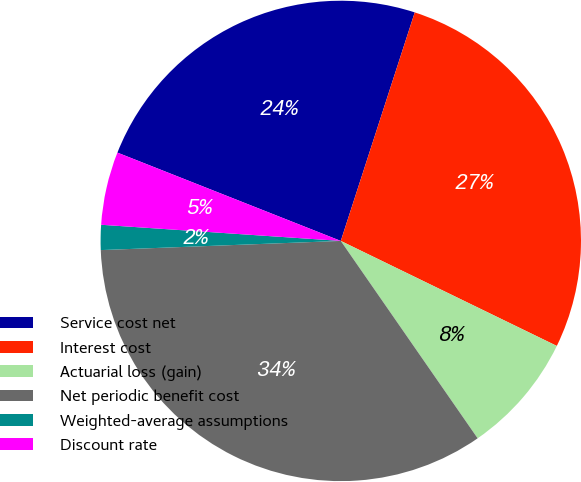Convert chart. <chart><loc_0><loc_0><loc_500><loc_500><pie_chart><fcel>Service cost net<fcel>Interest cost<fcel>Actuarial loss (gain)<fcel>Net periodic benefit cost<fcel>Weighted-average assumptions<fcel>Discount rate<nl><fcel>23.99%<fcel>27.22%<fcel>8.15%<fcel>34.04%<fcel>1.68%<fcel>4.92%<nl></chart> 